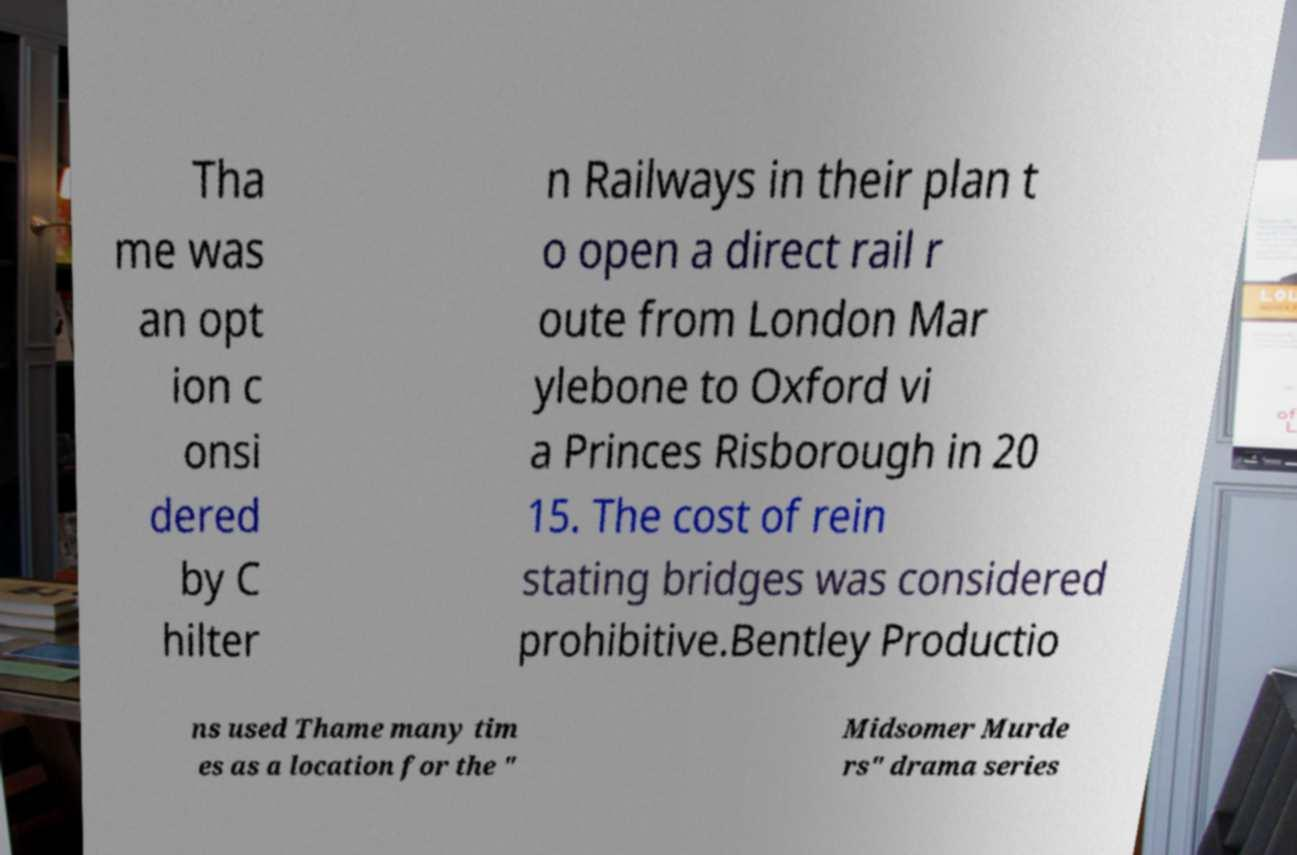Can you read and provide the text displayed in the image?This photo seems to have some interesting text. Can you extract and type it out for me? Tha me was an opt ion c onsi dered by C hilter n Railways in their plan t o open a direct rail r oute from London Mar ylebone to Oxford vi a Princes Risborough in 20 15. The cost of rein stating bridges was considered prohibitive.Bentley Productio ns used Thame many tim es as a location for the " Midsomer Murde rs" drama series 